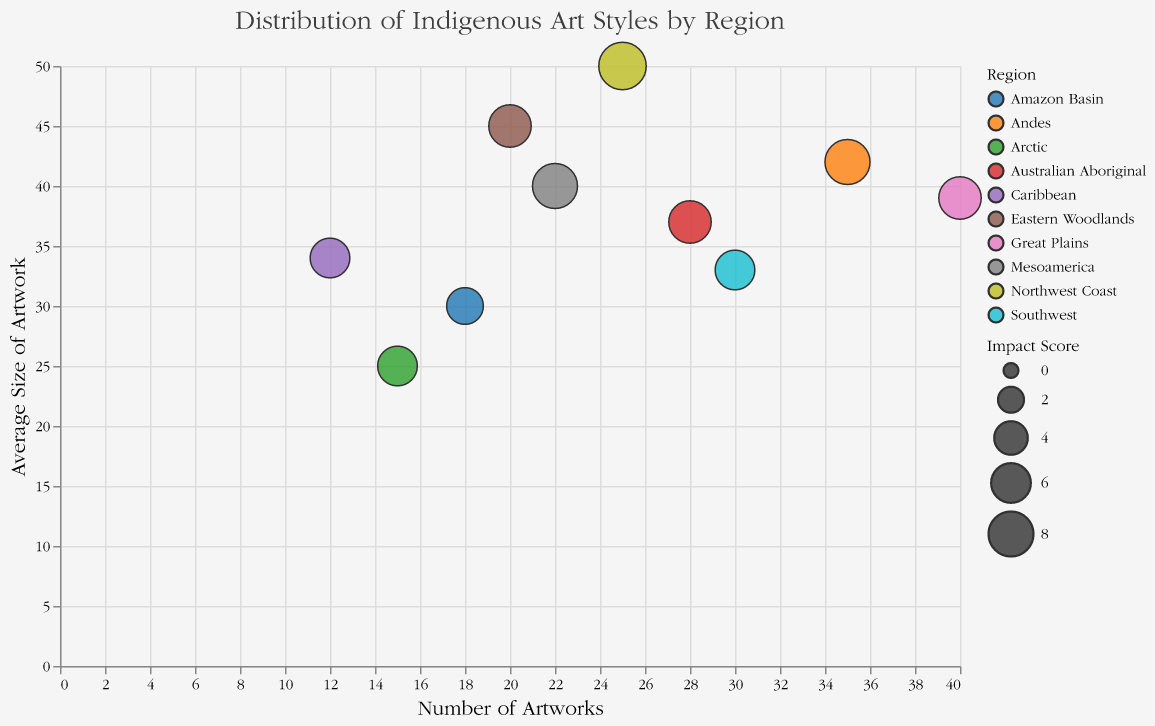What's the title of the figure? The title is usually displayed at the top of the figure and is rendered by the title attribute in the plot's metadata.
Answer: Distribution of Indigenous Art Styles by Region How is the x-axis labeled? The label of the x-axis can be found at the bottom of the x-axis, which usually indicates what the axis values represent.
Answer: Number of Artworks Which region has the highest average size of artwork? To find this, look at the y-axis values and identify the highest bubble. The tooltip or color legend can then be used to see which region it belongs to.
Answer: Northwest Coast What is the relationship between Count and Avg_Size for the Northwest Coast region? The bubble for the Northwest Coast can be found based on its color or tooltip. The Count and Avg_Size values are then read directly from the respective axes.
Answer: 25 artworks, 50 average size Which region appears to have the lowest impact score? Impact Score is depicted by the size of the bubbles. The smallest bubble will have the lowest impact score.
Answer: Amazon Basin How many regions have more than 30 artworks? Count the number of bubbles that have their x-axis value (Count) greater than 30.
Answer: 3 regions Compare the Count of artworks between Andes and Great Plains. Locate the bubbles for Andes and Great Plains by their color or tooltip. Then compare their positions on the x-axis.
Answer: Great Plains has more artworks than Andes What techniques influenced the indigenous styles in the Caribbean and Arctic regions? Inspect the tooltip for the bubbles corresponding to the Caribbean and Arctic regions to identify the mentioned European Influence Techniques.
Answer: Knitting for Caribbean, Metal Working for Arctic Which region has an impact score of 9 and what is their indigenous art style? The tooltips can be used to find the bubble with an Impact Score of 9. The data within the tooltip will provide both the region and the indigenous art style.
Answer: Northwest Coast, Totem Poles What region has the highest combined total of Count and Avg_Size? Add the Count and Avg_Size for each region, and find the one with the highest result.
Answer: Northwest Coast 